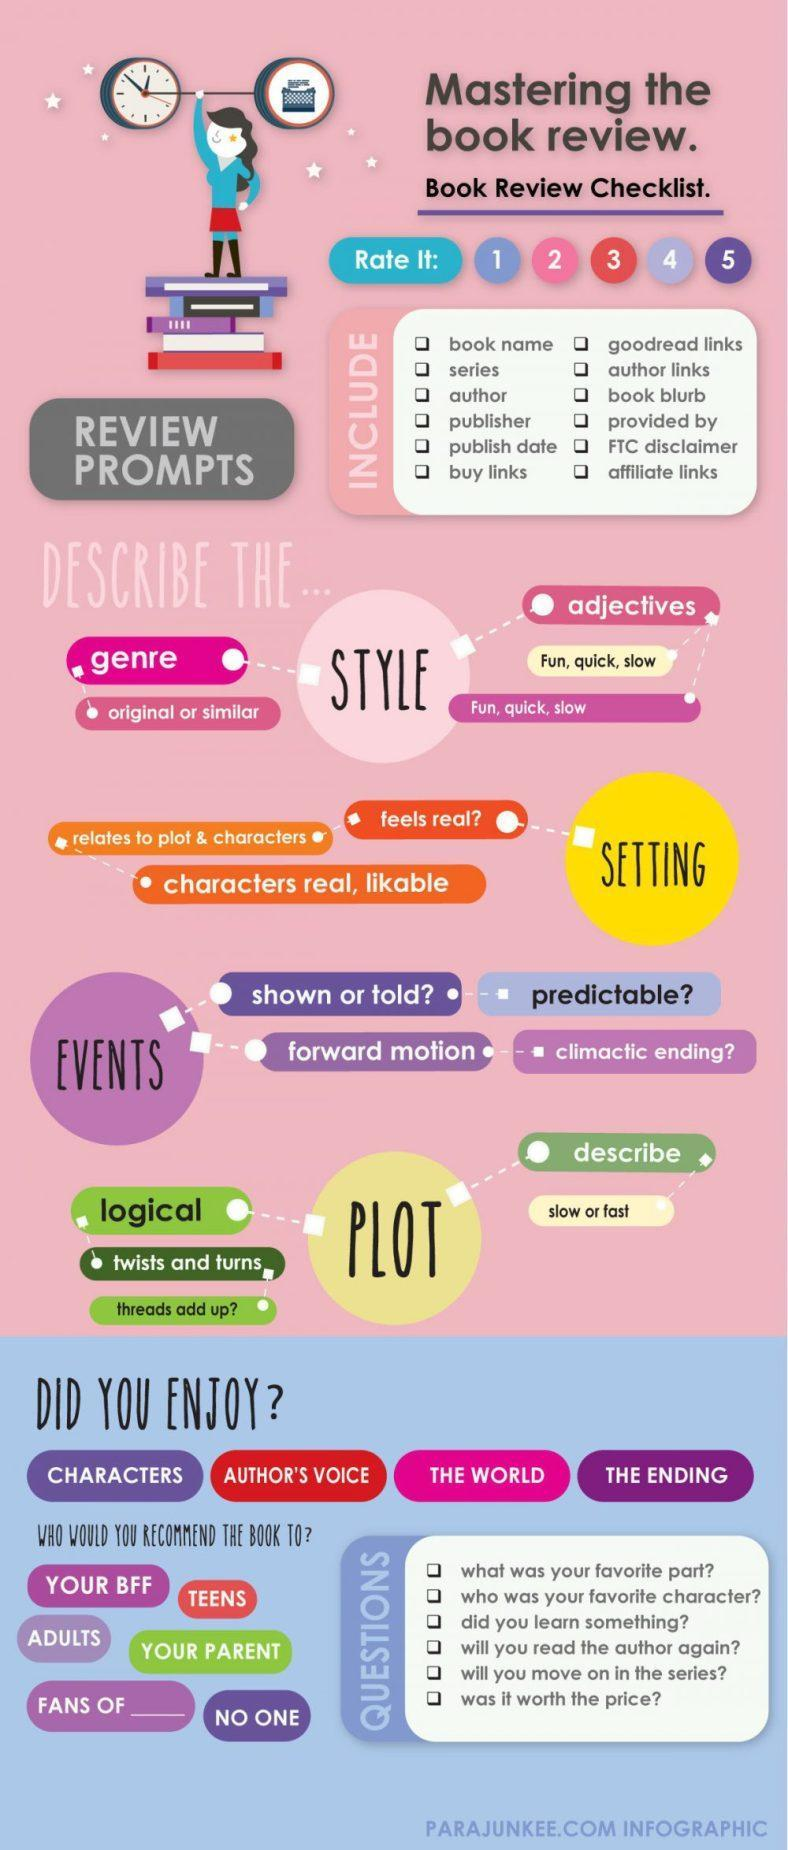How many prompts should be considered in a book review
Answer the question with a short phrase. 12 What is the acronym for best friend forever BFF How can the plot speed be described slow or fast what is the minimum rating 1 How many questions to ask in order to recommend the book 6 Other than characters, what other points should we enjoy author's voice, the world, the ending what is the maximum rating 5 